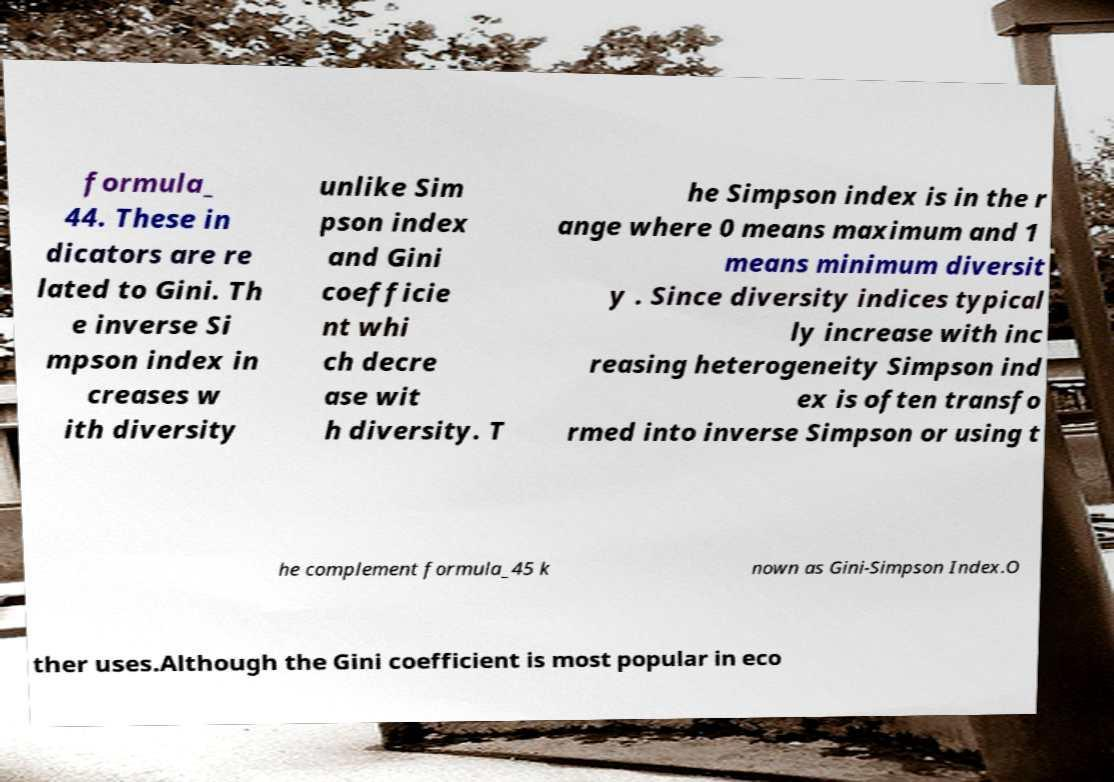Can you accurately transcribe the text from the provided image for me? formula_ 44. These in dicators are re lated to Gini. Th e inverse Si mpson index in creases w ith diversity unlike Sim pson index and Gini coefficie nt whi ch decre ase wit h diversity. T he Simpson index is in the r ange where 0 means maximum and 1 means minimum diversit y . Since diversity indices typical ly increase with inc reasing heterogeneity Simpson ind ex is often transfo rmed into inverse Simpson or using t he complement formula_45 k nown as Gini-Simpson Index.O ther uses.Although the Gini coefficient is most popular in eco 